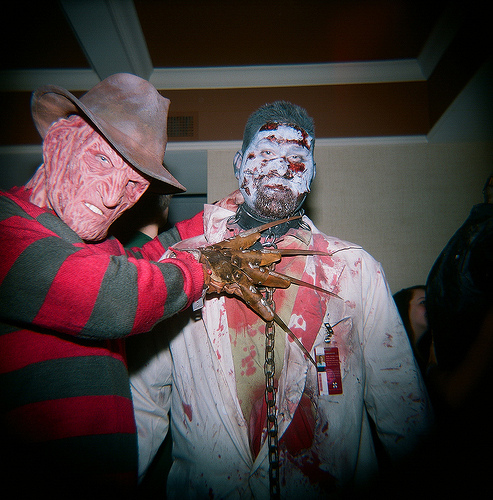<image>
Is the collar under the head? Yes. The collar is positioned underneath the head, with the head above it in the vertical space. Is there a fingernail behind the man? No. The fingernail is not behind the man. From this viewpoint, the fingernail appears to be positioned elsewhere in the scene. 